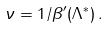Convert formula to latex. <formula><loc_0><loc_0><loc_500><loc_500>\nu = 1 / \beta ^ { \prime } ( \Lambda ^ { * } ) \, .</formula> 